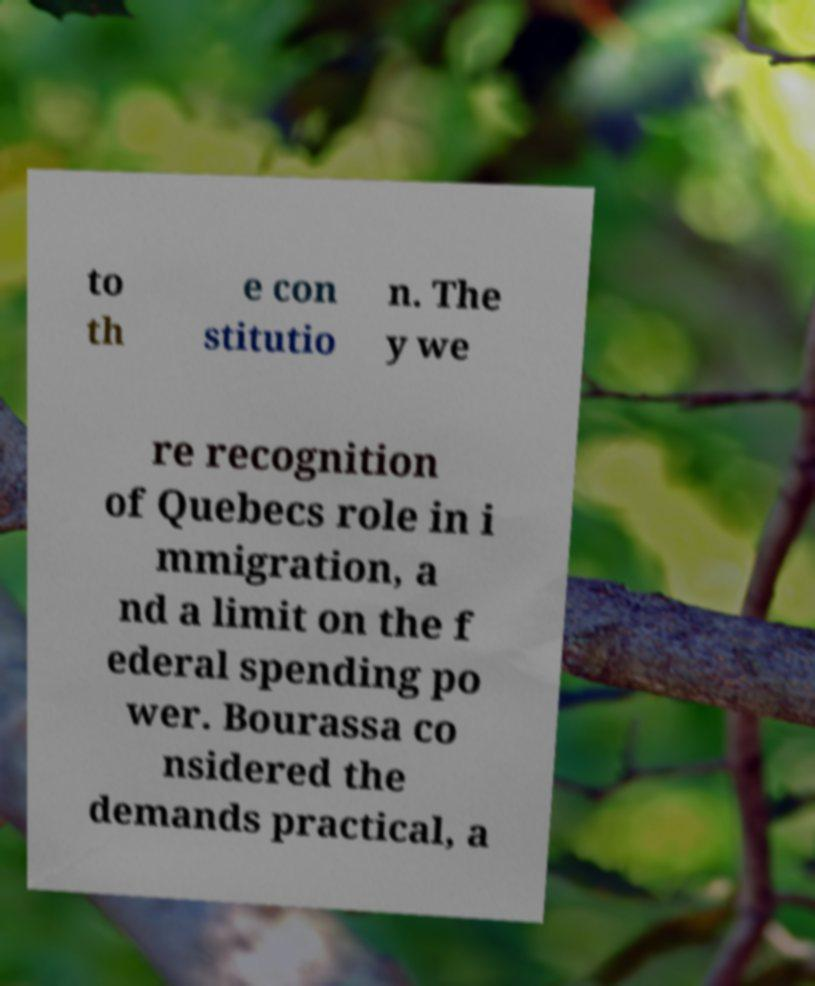There's text embedded in this image that I need extracted. Can you transcribe it verbatim? to th e con stitutio n. The y we re recognition of Quebecs role in i mmigration, a nd a limit on the f ederal spending po wer. Bourassa co nsidered the demands practical, a 